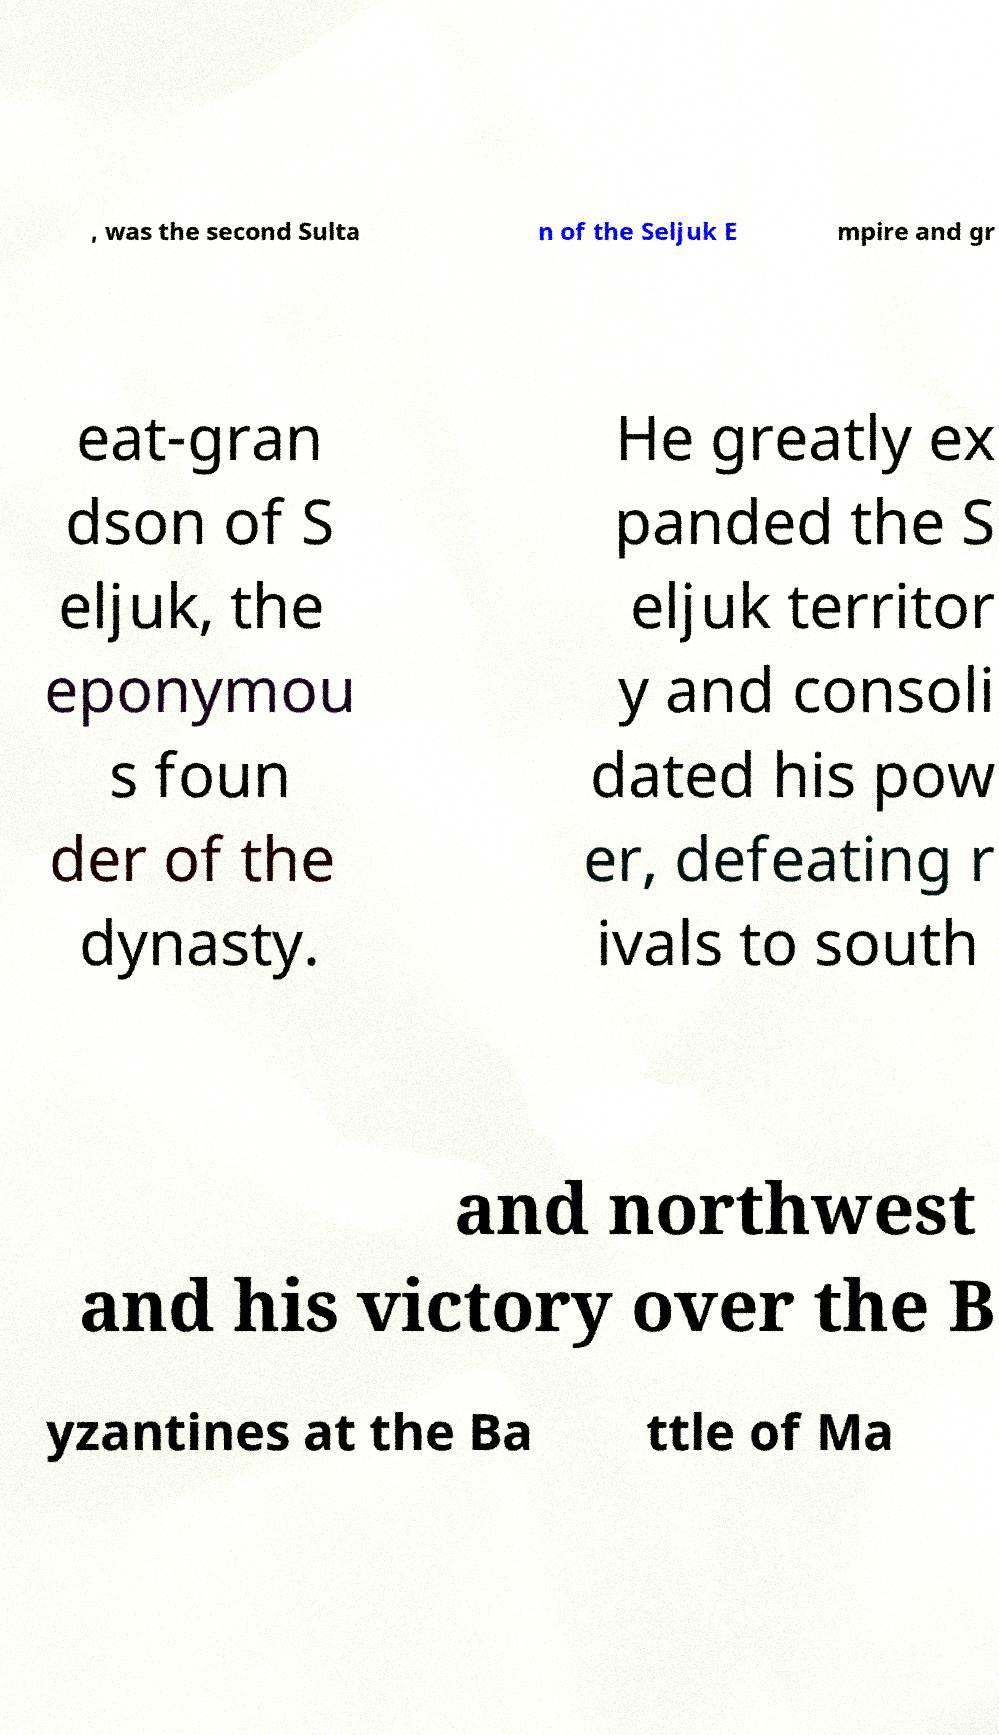Can you accurately transcribe the text from the provided image for me? , was the second Sulta n of the Seljuk E mpire and gr eat-gran dson of S eljuk, the eponymou s foun der of the dynasty. He greatly ex panded the S eljuk territor y and consoli dated his pow er, defeating r ivals to south and northwest and his victory over the B yzantines at the Ba ttle of Ma 